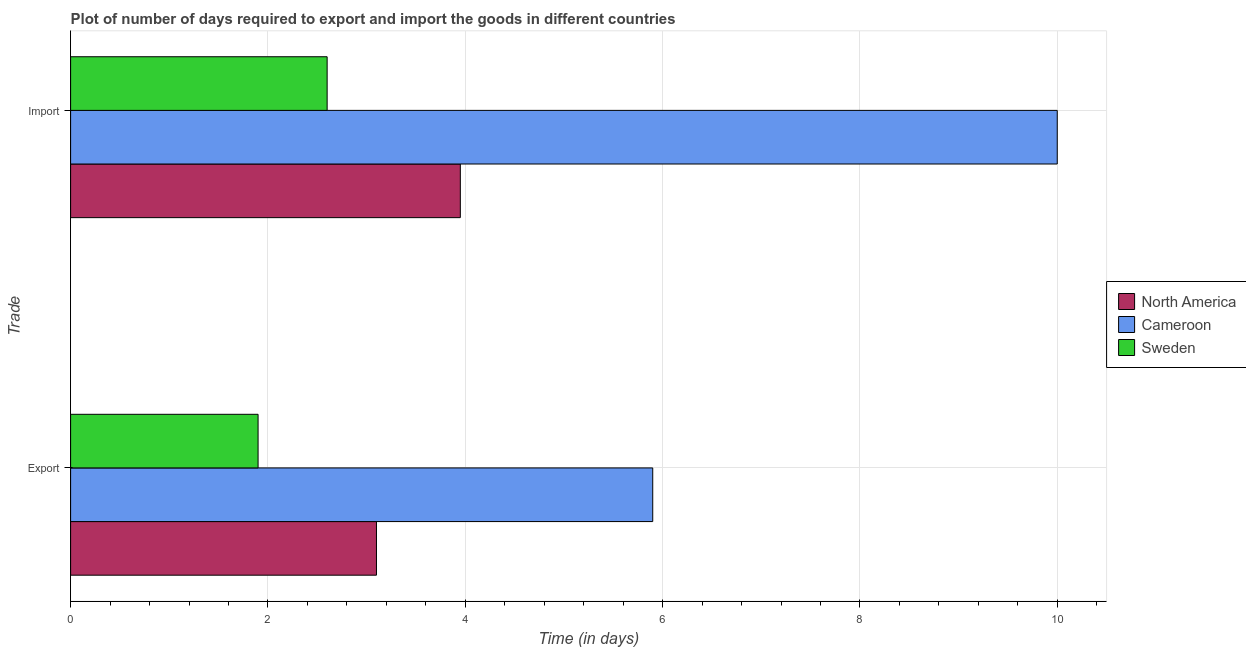How many different coloured bars are there?
Provide a succinct answer. 3. Are the number of bars on each tick of the Y-axis equal?
Your answer should be compact. Yes. How many bars are there on the 2nd tick from the top?
Make the answer very short. 3. How many bars are there on the 2nd tick from the bottom?
Your response must be concise. 3. What is the label of the 2nd group of bars from the top?
Offer a very short reply. Export. What is the time required to import in North America?
Make the answer very short. 3.95. In which country was the time required to export maximum?
Give a very brief answer. Cameroon. What is the total time required to import in the graph?
Your answer should be compact. 16.55. What is the difference between the time required to import in Sweden and that in Cameroon?
Make the answer very short. -7.4. What is the difference between the time required to import in North America and the time required to export in Cameroon?
Give a very brief answer. -1.95. What is the average time required to export per country?
Your answer should be compact. 3.63. What is the difference between the time required to import and time required to export in North America?
Offer a very short reply. 0.85. In how many countries, is the time required to import greater than 8 days?
Your response must be concise. 1. What is the ratio of the time required to export in Sweden to that in Cameroon?
Give a very brief answer. 0.32. Is the time required to import in Sweden less than that in North America?
Ensure brevity in your answer.  Yes. What does the 2nd bar from the bottom in Import represents?
Provide a short and direct response. Cameroon. How many bars are there?
Give a very brief answer. 6. How many countries are there in the graph?
Your answer should be very brief. 3. Does the graph contain any zero values?
Make the answer very short. No. Does the graph contain grids?
Keep it short and to the point. Yes. Where does the legend appear in the graph?
Offer a terse response. Center right. What is the title of the graph?
Your response must be concise. Plot of number of days required to export and import the goods in different countries. What is the label or title of the X-axis?
Provide a succinct answer. Time (in days). What is the label or title of the Y-axis?
Offer a terse response. Trade. What is the Time (in days) of North America in Import?
Keep it short and to the point. 3.95. What is the Time (in days) of Cameroon in Import?
Your answer should be compact. 10. Across all Trade, what is the maximum Time (in days) of North America?
Give a very brief answer. 3.95. Across all Trade, what is the maximum Time (in days) of Cameroon?
Your answer should be compact. 10. Across all Trade, what is the maximum Time (in days) in Sweden?
Your answer should be compact. 2.6. Across all Trade, what is the minimum Time (in days) in Sweden?
Ensure brevity in your answer.  1.9. What is the total Time (in days) in North America in the graph?
Your response must be concise. 7.05. What is the total Time (in days) of Sweden in the graph?
Offer a terse response. 4.5. What is the difference between the Time (in days) of North America in Export and that in Import?
Give a very brief answer. -0.85. What is the difference between the Time (in days) of Sweden in Export and that in Import?
Provide a short and direct response. -0.7. What is the difference between the Time (in days) of North America in Export and the Time (in days) of Cameroon in Import?
Your response must be concise. -6.9. What is the difference between the Time (in days) in North America in Export and the Time (in days) in Sweden in Import?
Your response must be concise. 0.5. What is the difference between the Time (in days) of Cameroon in Export and the Time (in days) of Sweden in Import?
Offer a terse response. 3.3. What is the average Time (in days) of North America per Trade?
Provide a succinct answer. 3.52. What is the average Time (in days) of Cameroon per Trade?
Provide a succinct answer. 7.95. What is the average Time (in days) in Sweden per Trade?
Keep it short and to the point. 2.25. What is the difference between the Time (in days) in North America and Time (in days) in Sweden in Export?
Offer a very short reply. 1.2. What is the difference between the Time (in days) in Cameroon and Time (in days) in Sweden in Export?
Offer a terse response. 4. What is the difference between the Time (in days) in North America and Time (in days) in Cameroon in Import?
Ensure brevity in your answer.  -6.05. What is the difference between the Time (in days) in North America and Time (in days) in Sweden in Import?
Provide a succinct answer. 1.35. What is the ratio of the Time (in days) of North America in Export to that in Import?
Make the answer very short. 0.78. What is the ratio of the Time (in days) in Cameroon in Export to that in Import?
Make the answer very short. 0.59. What is the ratio of the Time (in days) of Sweden in Export to that in Import?
Your answer should be very brief. 0.73. What is the difference between the highest and the second highest Time (in days) of Cameroon?
Provide a succinct answer. 4.1. What is the difference between the highest and the second highest Time (in days) in Sweden?
Offer a terse response. 0.7. What is the difference between the highest and the lowest Time (in days) of Cameroon?
Keep it short and to the point. 4.1. 